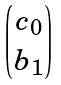Convert formula to latex. <formula><loc_0><loc_0><loc_500><loc_500>\begin{pmatrix} c _ { 0 } \\ b _ { 1 } \end{pmatrix}</formula> 